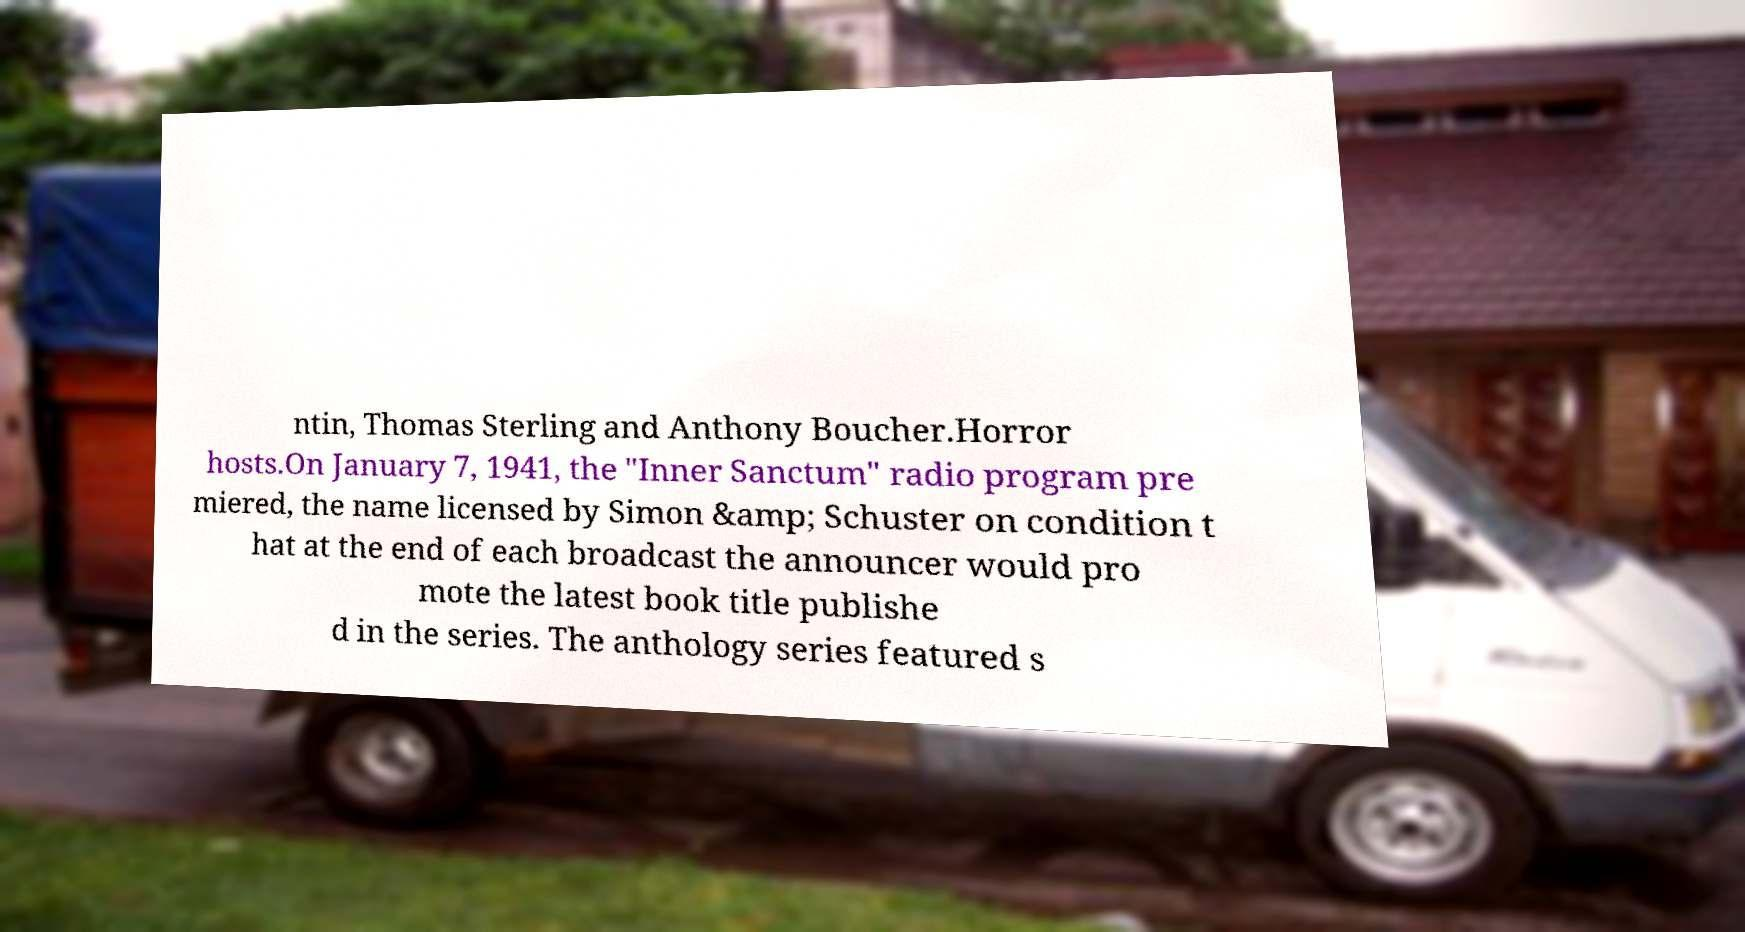There's text embedded in this image that I need extracted. Can you transcribe it verbatim? ntin, Thomas Sterling and Anthony Boucher.Horror hosts.On January 7, 1941, the "Inner Sanctum" radio program pre miered, the name licensed by Simon &amp; Schuster on condition t hat at the end of each broadcast the announcer would pro mote the latest book title publishe d in the series. The anthology series featured s 